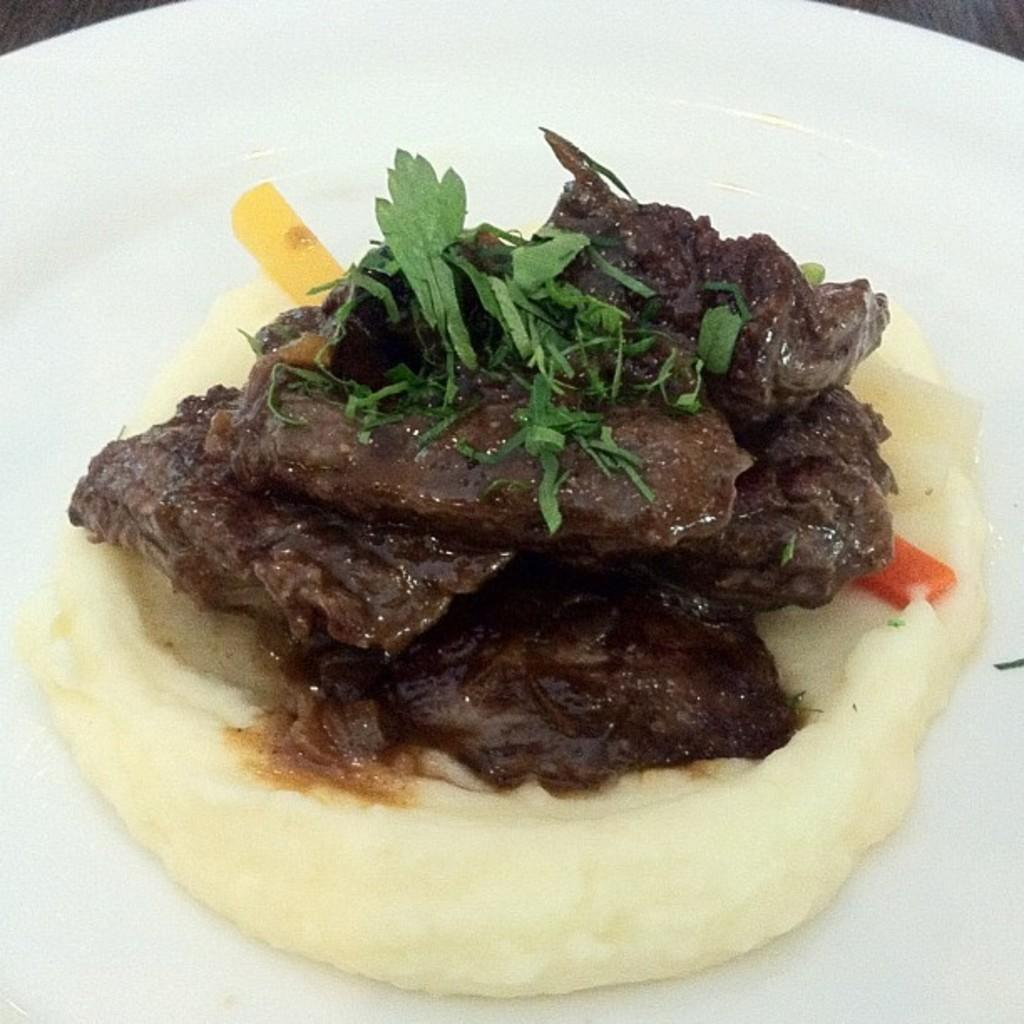What is placed on the table in the image? There is an eatable item placed on a table in the image. How many cacti are visible in the image? There are no cacti present in the image. What type of clouds can be seen in the image? There is no reference to clouds in the image, as it only mentions an eatable item placed on a table. 